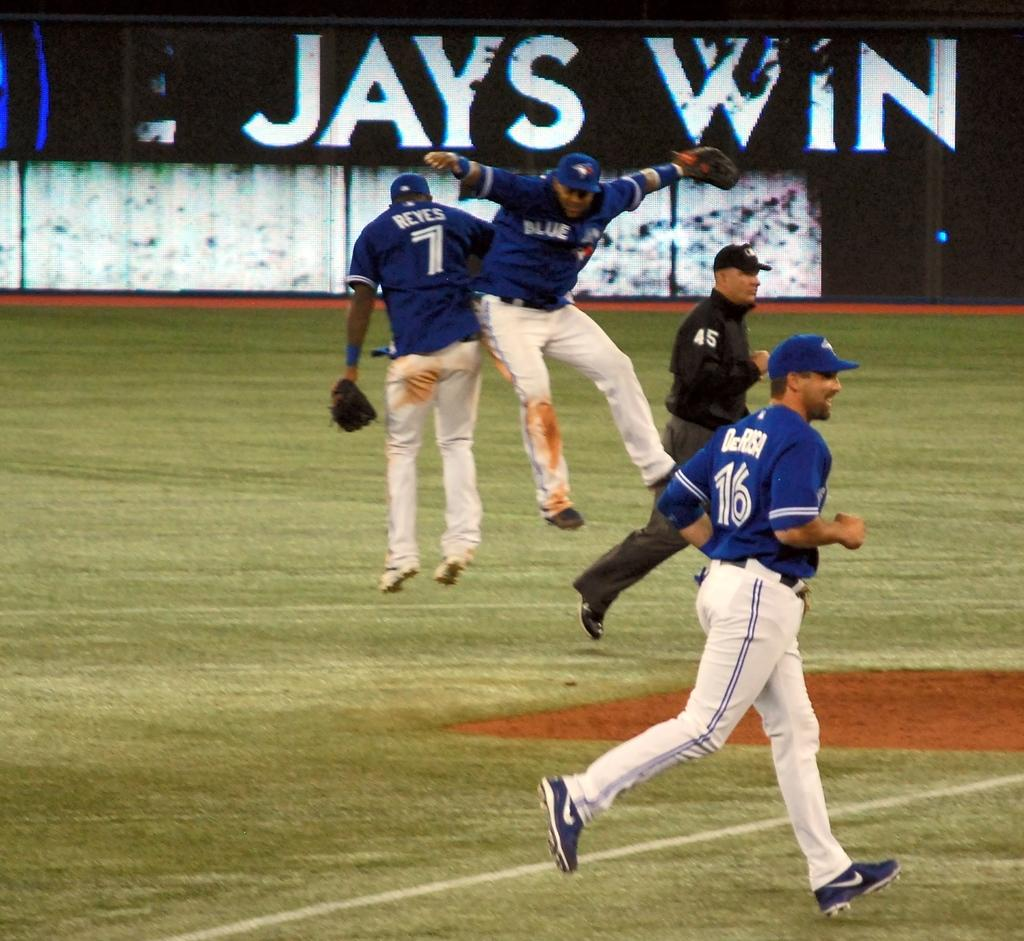<image>
Summarize the visual content of the image. A player jumps in the are in front of a sign that says the Jays win. 